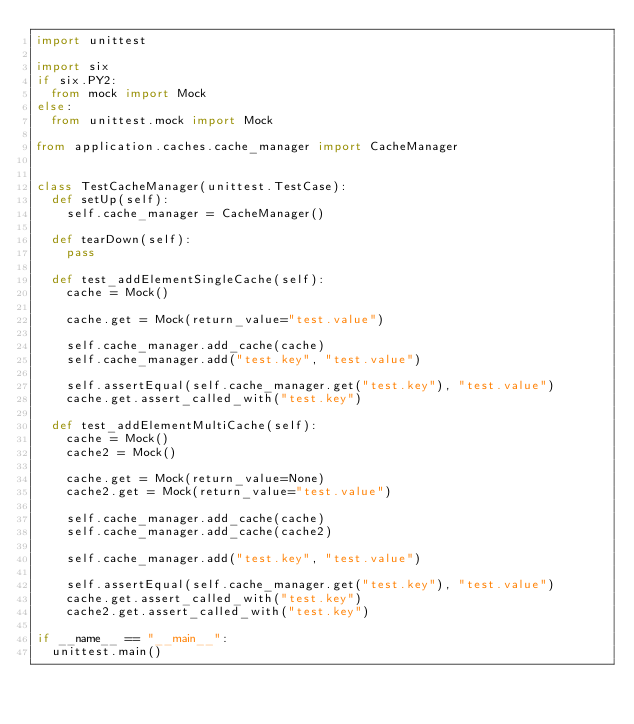Convert code to text. <code><loc_0><loc_0><loc_500><loc_500><_Python_>import unittest

import six
if six.PY2:
	from mock import Mock
else:
	from unittest.mock import Mock

from application.caches.cache_manager import CacheManager


class TestCacheManager(unittest.TestCase):
	def setUp(self):
		self.cache_manager = CacheManager()

	def tearDown(self):
		pass

	def test_addElementSingleCache(self):
		cache = Mock()

		cache.get = Mock(return_value="test.value")

		self.cache_manager.add_cache(cache)
		self.cache_manager.add("test.key", "test.value")

		self.assertEqual(self.cache_manager.get("test.key"), "test.value")
		cache.get.assert_called_with("test.key")

	def test_addElementMultiCache(self):
		cache = Mock()
		cache2 = Mock()

		cache.get = Mock(return_value=None)
		cache2.get = Mock(return_value="test.value")

		self.cache_manager.add_cache(cache)
		self.cache_manager.add_cache(cache2)

		self.cache_manager.add("test.key", "test.value")

		self.assertEqual(self.cache_manager.get("test.key"), "test.value")
		cache.get.assert_called_with("test.key")
		cache2.get.assert_called_with("test.key")

if __name__ == "__main__":
	unittest.main()</code> 